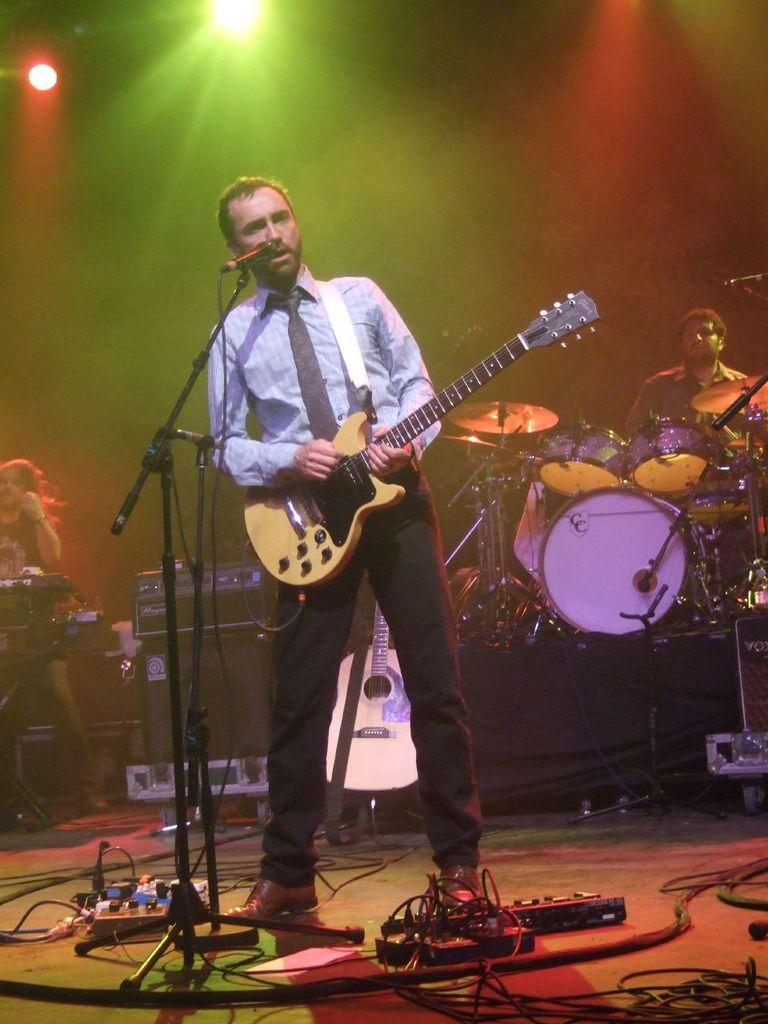What is the man in the image doing? There is a man standing in the image, and he is holding something in his hand. Can you describe the other person in the image? The second man in the image is playing drums. What might the man holding something be using? It is not clear from the image what the man is holding, so we cannot definitively say what he might be using it for. What type of belief is being discussed in the image? There is no indication in the image that a belief is being discussed. Can you see any fire in the image? There is no fire present in the image. 